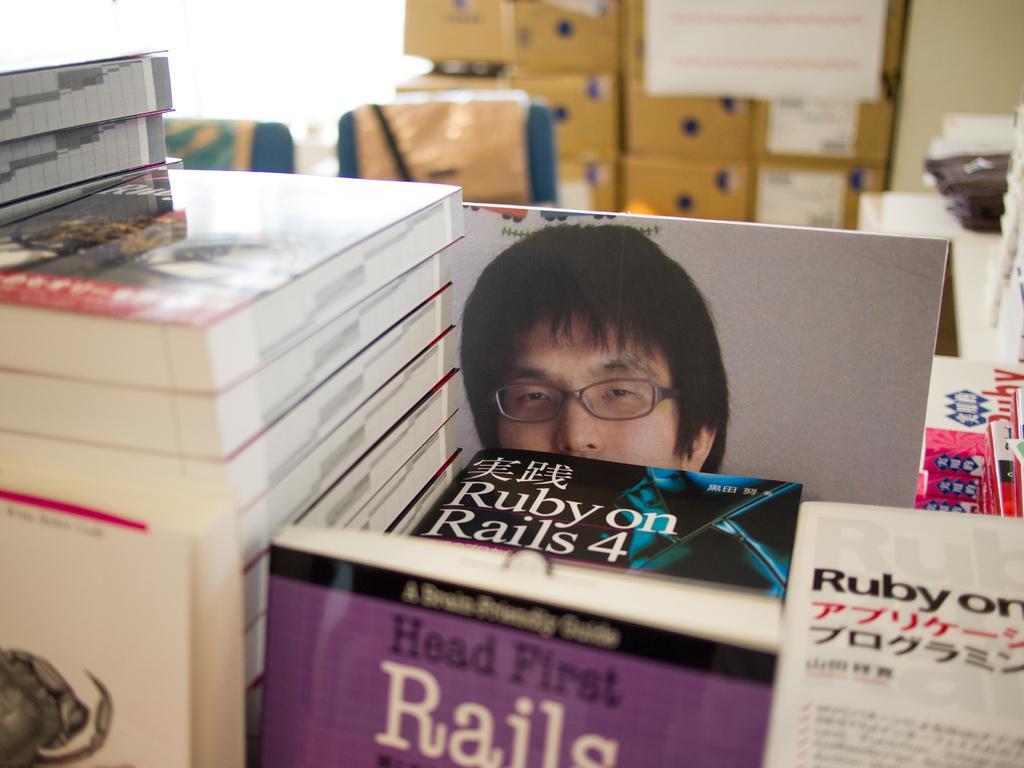Can you describe this image briefly? In this image we can see some books. We can also see a person on the whiteboard. In the background we can see some cardboard boxes and also two chairs. 